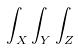Convert formula to latex. <formula><loc_0><loc_0><loc_500><loc_500>\int _ { X } \int _ { Y } \int _ { Z }</formula> 